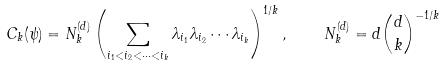Convert formula to latex. <formula><loc_0><loc_0><loc_500><loc_500>C _ { k } ( \psi ) = N _ { k } ^ { ( d ) } \left ( \sum _ { i _ { 1 } < i _ { 2 } < \dots < i _ { k } } \lambda _ { i _ { 1 } } \lambda _ { i _ { 2 } } \cdots \lambda _ { i _ { k } } \right ) ^ { 1 / k } , \quad N _ { k } ^ { ( d ) } = d { d \choose k } ^ { - 1 / k }</formula> 